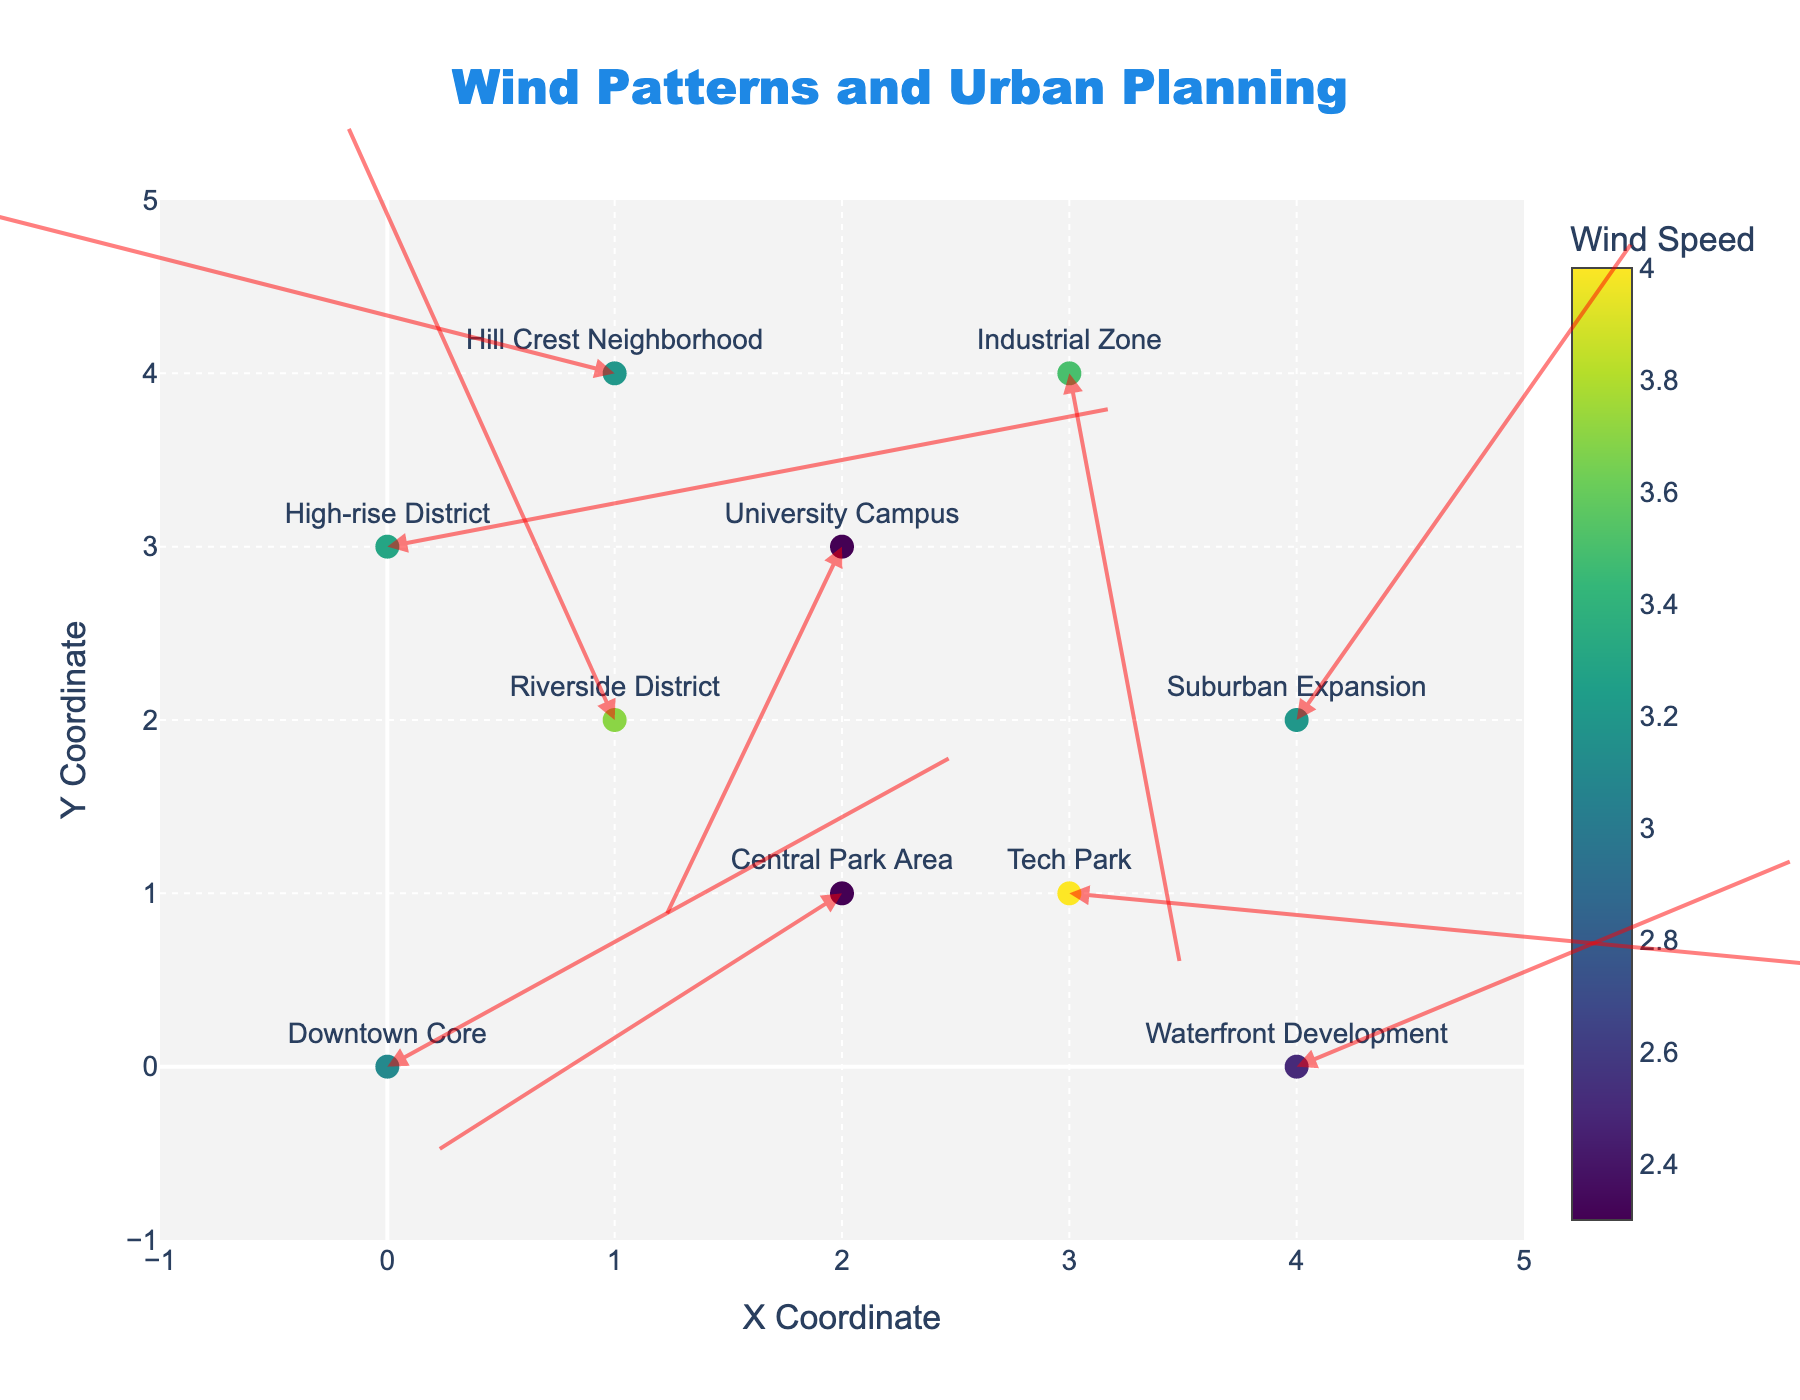What is the title of the figure? The title of the figure is prominently displayed at the top center of the plot in bold and large font.
Answer: Wind Patterns and Urban Planning How many locations are being analyzed in the figure? By looking at the data points and the number of locations labeled with text on the plot, we see there are 10 locations.
Answer: 10 In which location is the wind speed highest? The color scale from blue to yellow represents wind speed, with the highest wind speed at 4.0 (Tech Park), as indicated by the label and the corresponding darker color on the plot.
Answer: Tech Park How does the wind direction at Riverside District compare to that at Waterfront Development? The arrows show the direction of the wind. Riverside District has an arrow pointing upward and to the left, indicating north-west direction, while Waterfront Development has an arrow pointing upward to the right, indicating north-east direction.
Answer: Riverside District: North-west, Waterfront Development: North-east Which area has the lowest wind speed based on the color scale? By referring to the color scale, the lowest wind speed (2.3) corresponds to the lightest color and is at two locations: University Campus and Central Park Area.
Answer: University Campus and Central Park Area What is the general wind direction in the Industrial Zone? The arrow in the Industrial Zone points downward, indicating a southward wind direction.
Answer: Southward What is the average wind speed among Downtown Core, Tech Park, and Hill Crest Neighborhood? Adding up the wind speeds and dividing by the number of locations: (3.1 + 4.0 + 3.2) / 3 = 10.3 / 3 = 3.43
Answer: 3.43 Between the Suburban Expansion and High-rise District, which has a stronger wind magnitude and by how much? Suburban Expansion has a wind magnitude of 3.2 and High-rise District has 3.3. The difference in magnitude is 3.3 - 3.2 = 0.1.
Answer: High-rise District by 0.1 In which direction is the wind blowing in Central Park Area? Looking at the arrow direction in Central Park Area, it points downward to the left, indicating a south-west direction.
Answer: South-west Is there any location where the wind is moving predominantly in the western direction? Examining the arrows in the plot, the only location with a predominant westward direction is Central Park Area, where the arrow points left (westward).
Answer: Central Park Area 